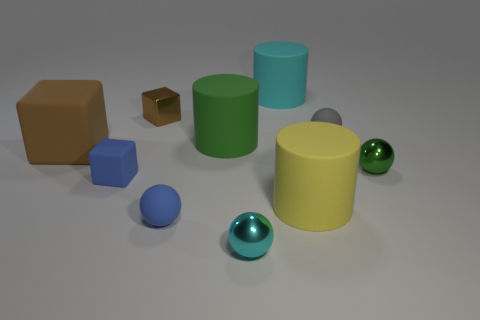Subtract all large brown blocks. How many blocks are left? 2 Subtract all cylinders. How many objects are left? 7 Subtract all gray cylinders. How many green balls are left? 1 Subtract all blue rubber blocks. Subtract all big cyan rubber balls. How many objects are left? 9 Add 1 tiny things. How many tiny things are left? 7 Add 6 small brown cubes. How many small brown cubes exist? 7 Subtract all green spheres. How many spheres are left? 3 Subtract 1 gray spheres. How many objects are left? 9 Subtract 1 cylinders. How many cylinders are left? 2 Subtract all yellow cubes. Subtract all yellow cylinders. How many cubes are left? 3 